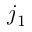<formula> <loc_0><loc_0><loc_500><loc_500>j _ { 1 }</formula> 